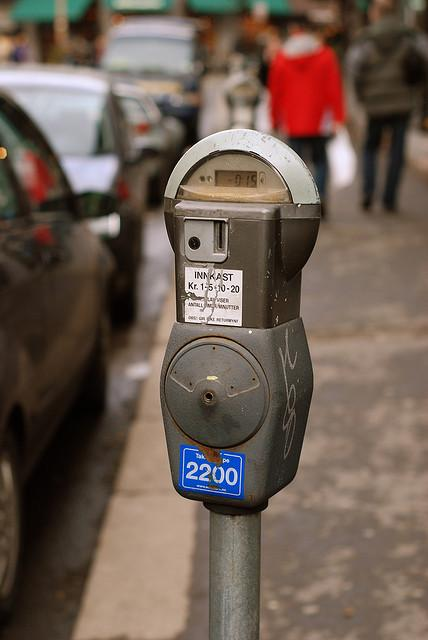What number do you get if you add 10 to the number at the bottom of the meter? Please explain your reasoning. 2210. You get that number if you add 10. 